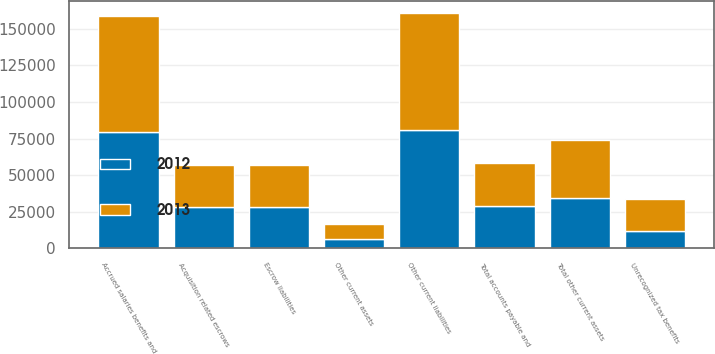Convert chart to OTSL. <chart><loc_0><loc_0><loc_500><loc_500><stacked_bar_chart><ecel><fcel>Acquisition related escrows<fcel>Other current assets<fcel>Total other current assets<fcel>Accrued salaries benefits and<fcel>Escrow liabilities<fcel>Other current liabilities<fcel>Total accounts payable and<fcel>Unrecognized tax benefits<nl><fcel>2012<fcel>27967<fcel>6714<fcel>34681<fcel>79372<fcel>27918<fcel>80974<fcel>29115.5<fcel>12143<nl><fcel>2013<fcel>29277<fcel>9832<fcel>39109<fcel>78979<fcel>28954<fcel>79715<fcel>29115.5<fcel>21611<nl></chart> 